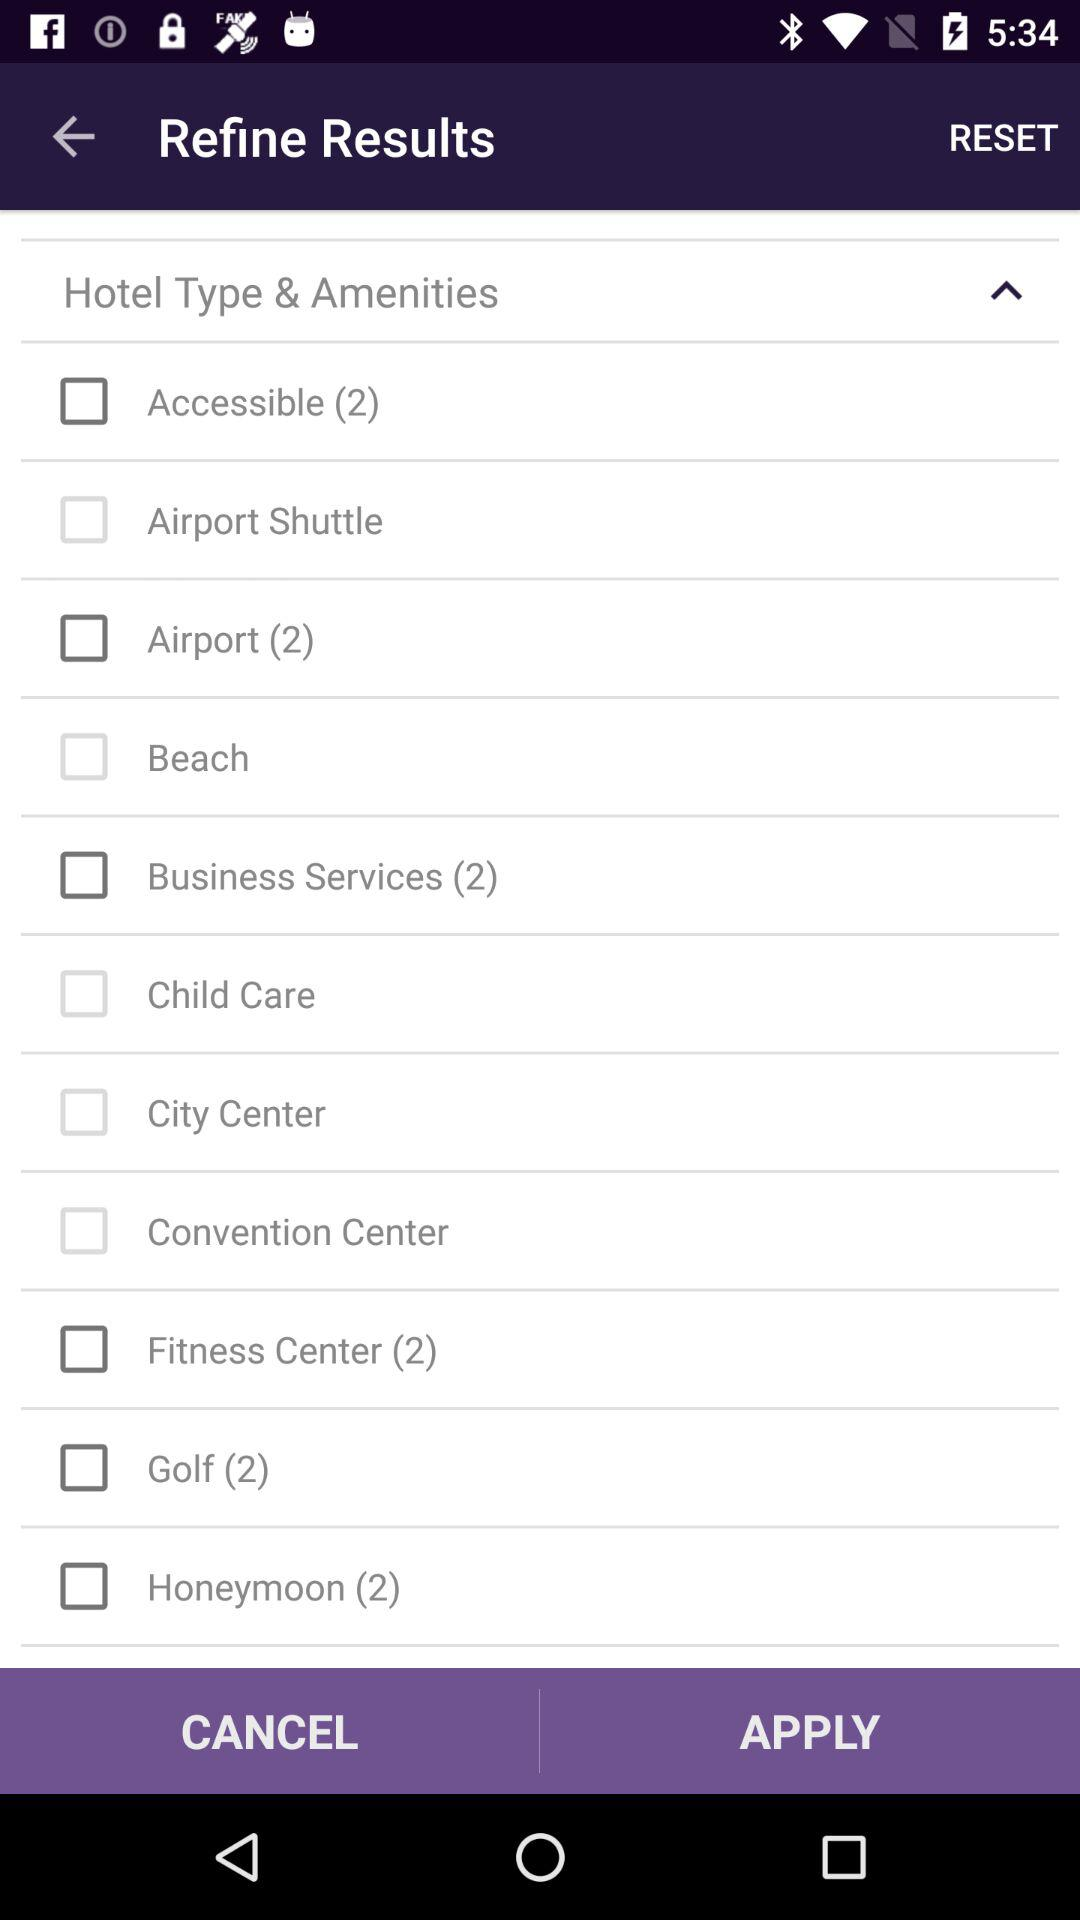What is the current status of "City Center"? The current status is "off". 